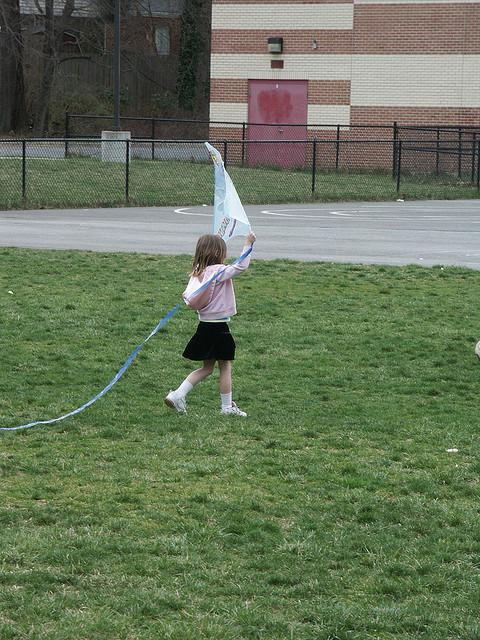What is in her right hand?
Keep it brief. Kite. Are there leaves on the tree?
Be succinct. No. Is the fence touching the ground?
Concise answer only. Yes. Is the child wearing a red coat?
Answer briefly. No. Is there a car in the background?
Be succinct. No. Why is the paint discolored on the red door?
Keep it brief. Age. 